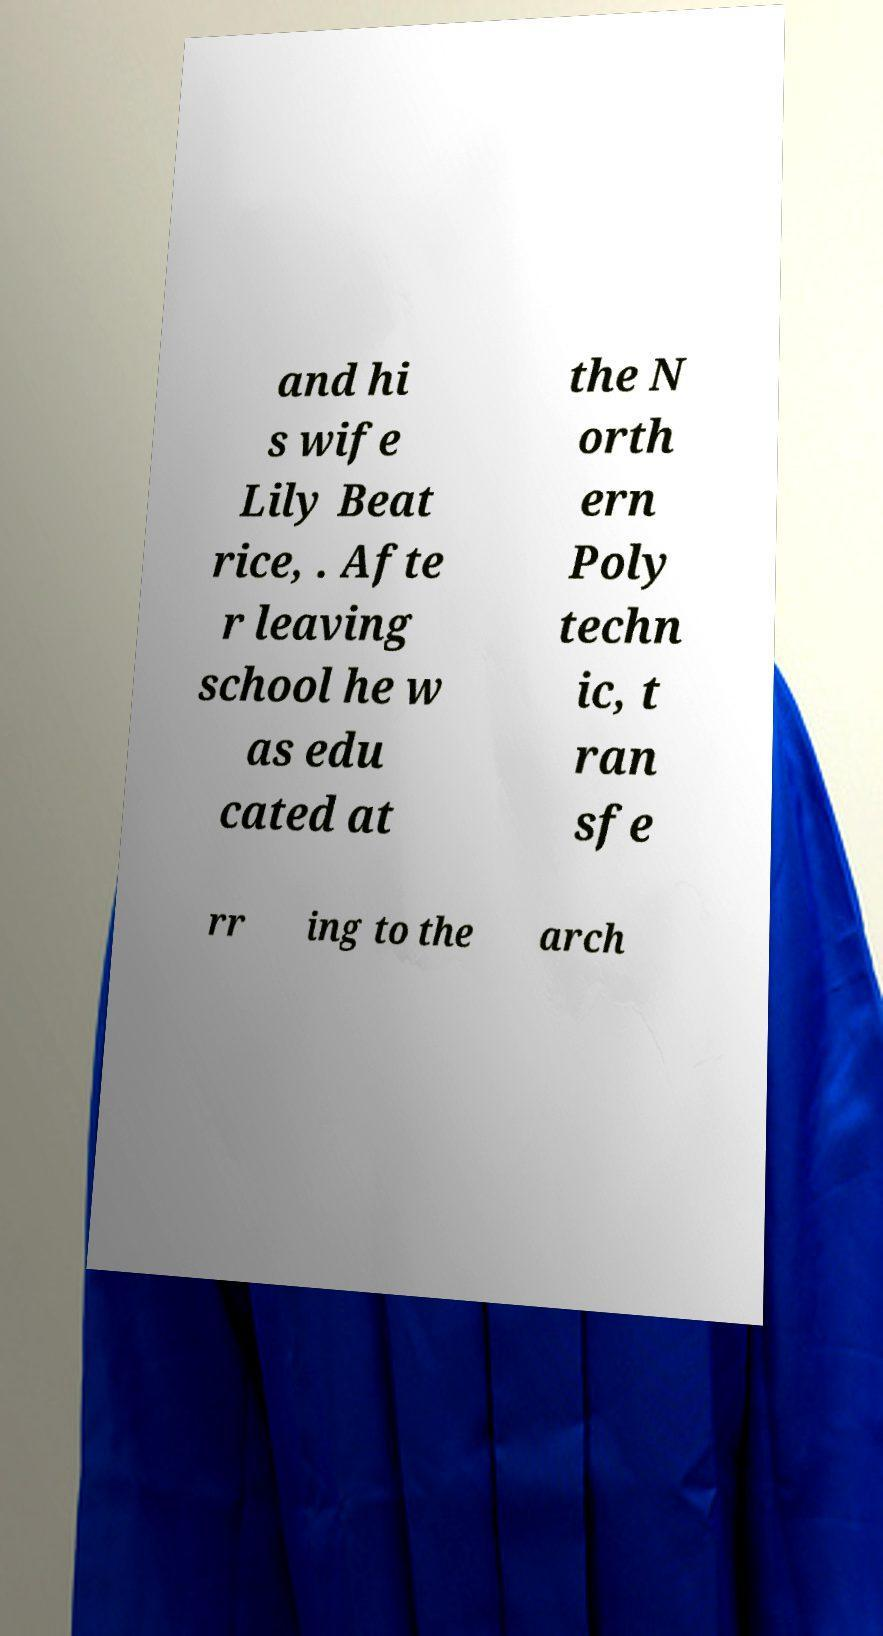What messages or text are displayed in this image? I need them in a readable, typed format. and hi s wife Lily Beat rice, . Afte r leaving school he w as edu cated at the N orth ern Poly techn ic, t ran sfe rr ing to the arch 